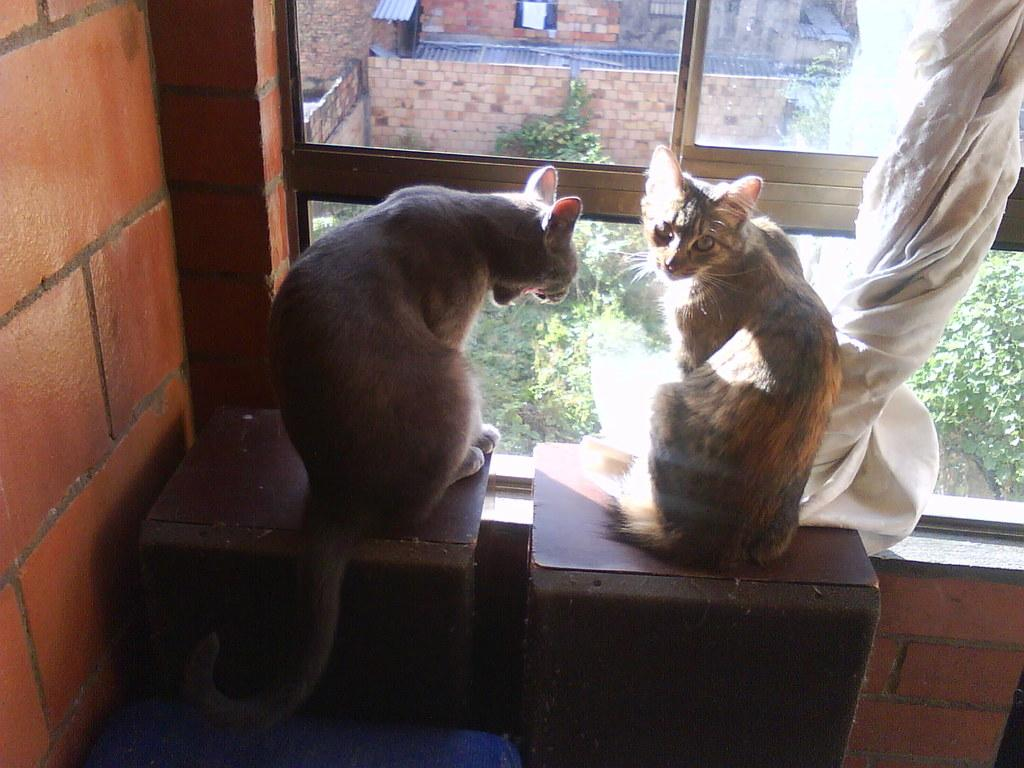How many cats are in the image? There are two cats in the image. Where are the cats located? The cats are on tables in the image. What is beside the tables? The tables are placed beside a window in the image. What is associated with the window? There is a curtain associated with the window. What can be seen in the background of the image? There is a group of plants visible in the background of the image. How many firemen are visible in the image? There are no firemen present in the image. What is the amount of pest visible in the image? There is no mention of pests in the image, so it cannot be determined if any are present or their amount. 